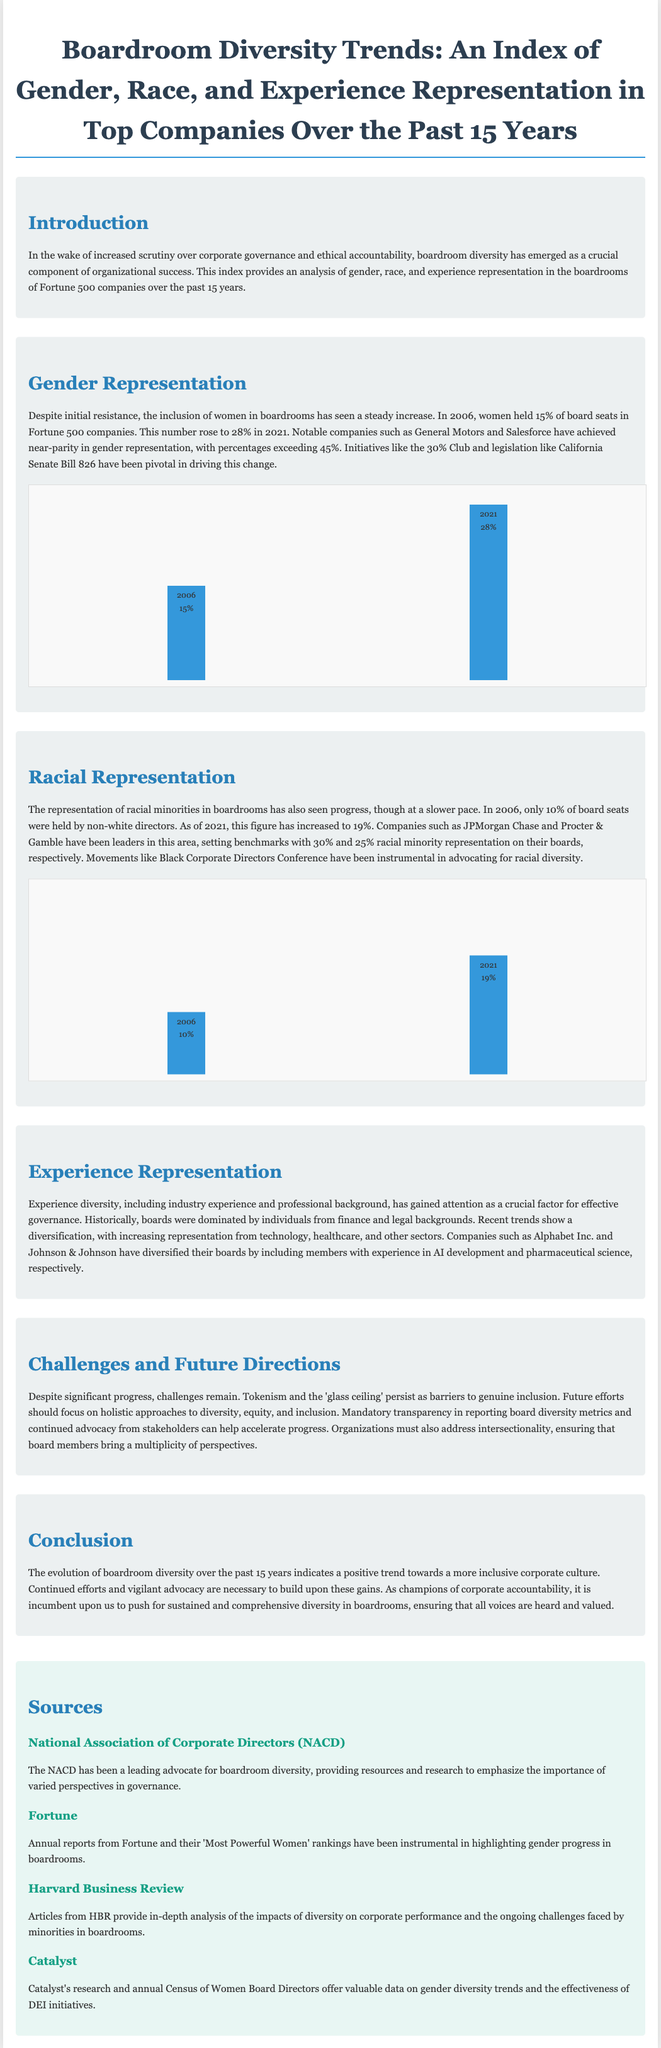what percentage of board seats were held by women in 2006? The document states that in 2006, women held 15% of board seats in Fortune 500 companies.
Answer: 15% what is the percentage of racial minority representation on JPMorgan Chase's board? The document mentions that JPMorgan Chase has 30% racial minority representation on its board.
Answer: 30% how much did the representation of women in boardrooms increase from 2006 to 2021? The increase from 2006 (15%) to 2021 (28%) is 13 percentage points.
Answer: 13 percentage points what were the percentages of non-white directors in boardrooms in 2006 and 2021? In 2006 it was 10%, and in 2021 it rose to 19%, showing a growth in representation.
Answer: 10% and 19% which two companies are noted for near-parity in gender representation? General Motors and Salesforce are highlighted for having gender representation percentages exceeding 45%.
Answer: General Motors and Salesforce what is the main challenge mentioned for boardroom diversity? The document identifies tokenism and the 'glass ceiling' as persistent barriers to genuine inclusion.
Answer: Tokenism and the 'glass ceiling' what is the role of the 30% Club? The 30% Club is mentioned as having been pivotal in driving the change toward increased female representation in boardrooms.
Answer: Pivotal in driving change which source provides data on gender diversity trends and DEI initiative effectiveness? Catalyst provides valuable data on gender diversity trends and the effectiveness of DEI initiatives.
Answer: Catalyst 